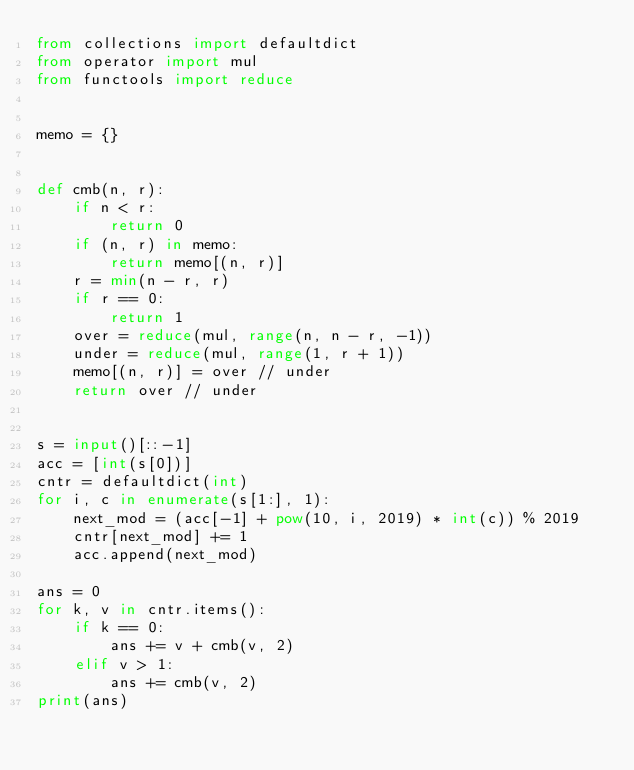Convert code to text. <code><loc_0><loc_0><loc_500><loc_500><_Python_>from collections import defaultdict
from operator import mul
from functools import reduce


memo = {}


def cmb(n, r):
    if n < r:
        return 0
    if (n, r) in memo:
        return memo[(n, r)]
    r = min(n - r, r)
    if r == 0:
        return 1
    over = reduce(mul, range(n, n - r, -1))
    under = reduce(mul, range(1, r + 1))
    memo[(n, r)] = over // under
    return over // under


s = input()[::-1]
acc = [int(s[0])]
cntr = defaultdict(int)
for i, c in enumerate(s[1:], 1):
    next_mod = (acc[-1] + pow(10, i, 2019) * int(c)) % 2019
    cntr[next_mod] += 1
    acc.append(next_mod)

ans = 0
for k, v in cntr.items():
    if k == 0:
        ans += v + cmb(v, 2)
    elif v > 1:
        ans += cmb(v, 2)
print(ans)
</code> 